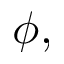Convert formula to latex. <formula><loc_0><loc_0><loc_500><loc_500>\phi ,</formula> 